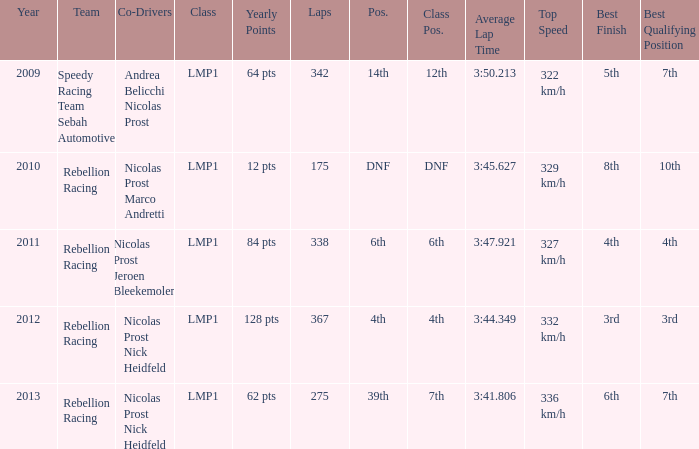What was the class position of the team that was in the 4th position? 4th. 